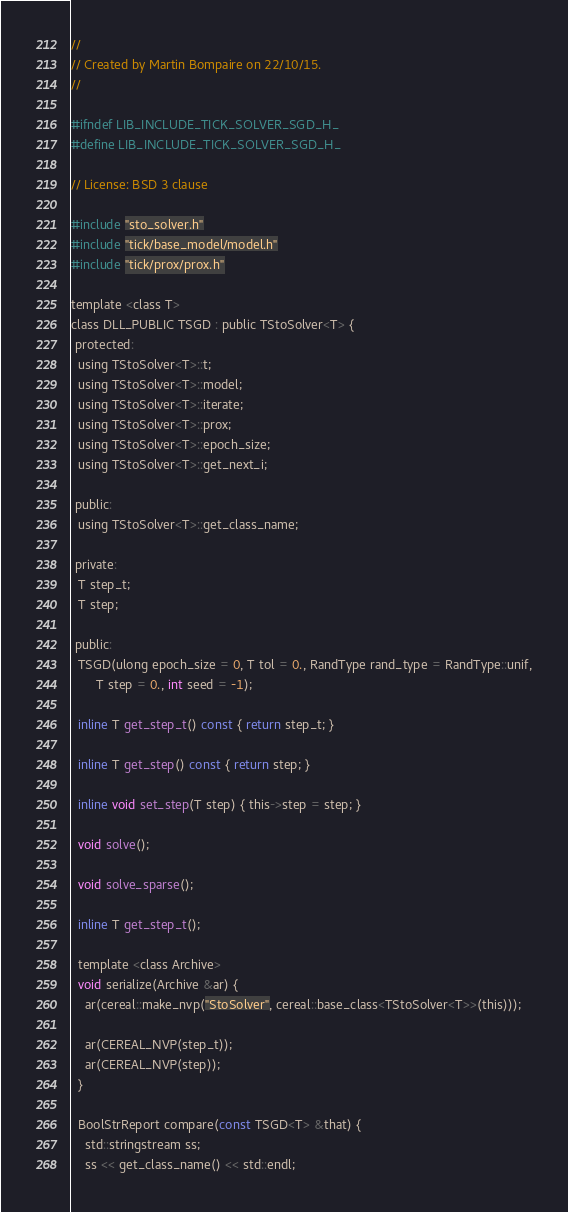<code> <loc_0><loc_0><loc_500><loc_500><_C_>//
// Created by Martin Bompaire on 22/10/15.
//

#ifndef LIB_INCLUDE_TICK_SOLVER_SGD_H_
#define LIB_INCLUDE_TICK_SOLVER_SGD_H_

// License: BSD 3 clause

#include "sto_solver.h"
#include "tick/base_model/model.h"
#include "tick/prox/prox.h"

template <class T>
class DLL_PUBLIC TSGD : public TStoSolver<T> {
 protected:
  using TStoSolver<T>::t;
  using TStoSolver<T>::model;
  using TStoSolver<T>::iterate;
  using TStoSolver<T>::prox;
  using TStoSolver<T>::epoch_size;
  using TStoSolver<T>::get_next_i;

 public:
  using TStoSolver<T>::get_class_name;

 private:
  T step_t;
  T step;

 public:
  TSGD(ulong epoch_size = 0, T tol = 0., RandType rand_type = RandType::unif,
       T step = 0., int seed = -1);

  inline T get_step_t() const { return step_t; }

  inline T get_step() const { return step; }

  inline void set_step(T step) { this->step = step; }

  void solve();

  void solve_sparse();

  inline T get_step_t();

  template <class Archive>
  void serialize(Archive &ar) {
    ar(cereal::make_nvp("StoSolver", cereal::base_class<TStoSolver<T>>(this)));

    ar(CEREAL_NVP(step_t));
    ar(CEREAL_NVP(step));
  }

  BoolStrReport compare(const TSGD<T> &that) {
    std::stringstream ss;
    ss << get_class_name() << std::endl;</code> 